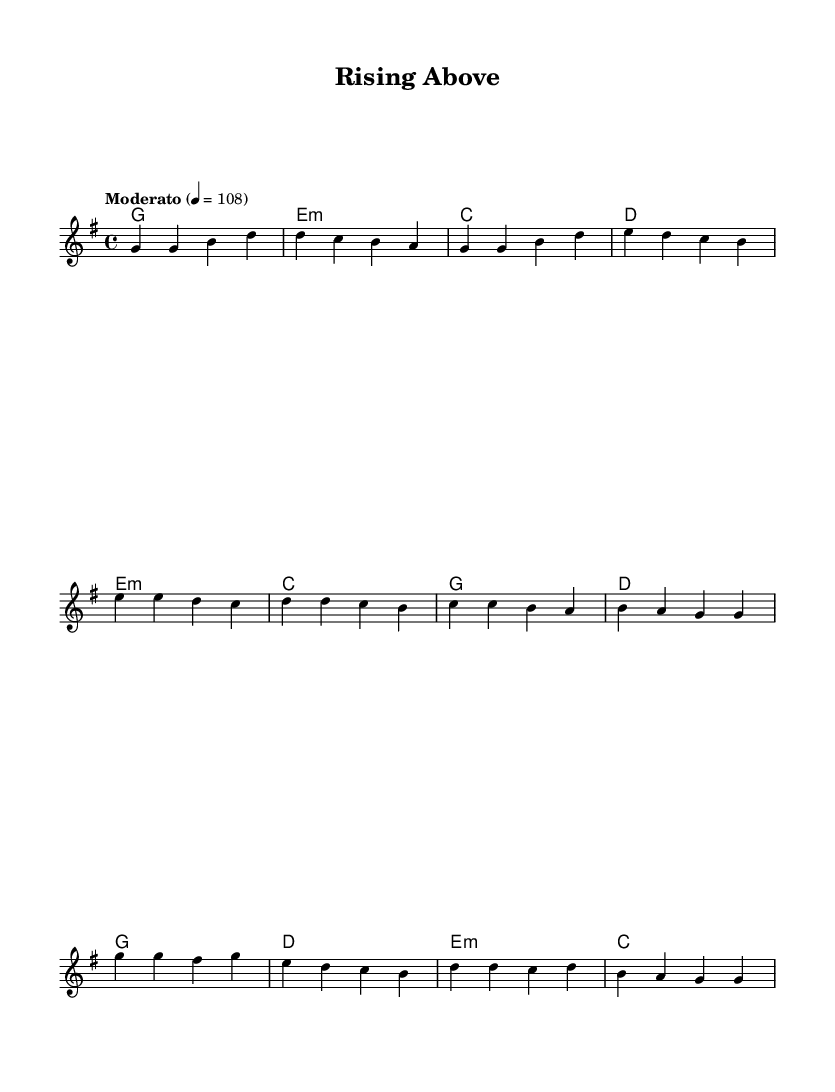What is the key signature of this music? The key signature indicates the presence of one sharp, which corresponds to the key of G major. The presence of an F# in the melody confirms this key.
Answer: G major What is the time signature of this music? The time signature is found at the beginning of the staff and indicates that there are four beats in each measure, characterized by the 4/4 notation.
Answer: 4/4 What is the tempo marking of this piece? The tempo marking specifies the speed of the piece, which is set at Moderato, meaning a moderate pace. The exact tempo of 108 beats per minute is also indicated.
Answer: Moderato How many measures are in the chorus section? By analyzing the structure of the sheet music, the chorus contains four measures as indicated by the grouping of the notes and rests.
Answer: 4 What type of chord is used in the pre-chorus? The chords listed in the pre-chorus section include E minor, C major, G major, and D major, which are standard pop chords used to enhance the emotional impact.
Answer: E minor Which note appears most frequently in the verse? Observing the melody of the verse, the note G occurs frequently at the beginning and throughout the section, appearing as the most repeated note.
Answer: G What is the last chord of the song? The last chord is designated in the harmonies, which shows that C major is the final chord leading to the conclusion of the piece.
Answer: C 